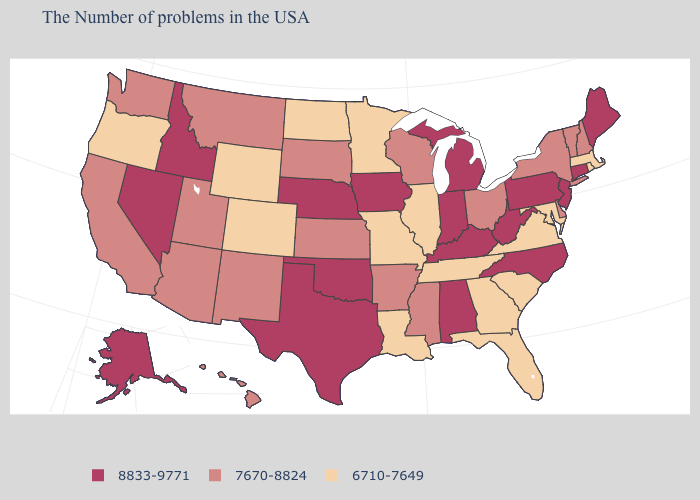Is the legend a continuous bar?
Quick response, please. No. Among the states that border Indiana , which have the lowest value?
Be succinct. Illinois. Among the states that border Louisiana , which have the highest value?
Write a very short answer. Texas. What is the value of Missouri?
Write a very short answer. 6710-7649. What is the value of Vermont?
Short answer required. 7670-8824. Among the states that border Delaware , does Maryland have the lowest value?
Answer briefly. Yes. What is the value of Ohio?
Give a very brief answer. 7670-8824. Does Missouri have the highest value in the MidWest?
Short answer required. No. Name the states that have a value in the range 7670-8824?
Be succinct. New Hampshire, Vermont, New York, Delaware, Ohio, Wisconsin, Mississippi, Arkansas, Kansas, South Dakota, New Mexico, Utah, Montana, Arizona, California, Washington, Hawaii. Name the states that have a value in the range 8833-9771?
Be succinct. Maine, Connecticut, New Jersey, Pennsylvania, North Carolina, West Virginia, Michigan, Kentucky, Indiana, Alabama, Iowa, Nebraska, Oklahoma, Texas, Idaho, Nevada, Alaska. What is the lowest value in states that border Alabama?
Short answer required. 6710-7649. How many symbols are there in the legend?
Concise answer only. 3. Does the first symbol in the legend represent the smallest category?
Be succinct. No. Does the map have missing data?
Write a very short answer. No. Does the map have missing data?
Quick response, please. No. 